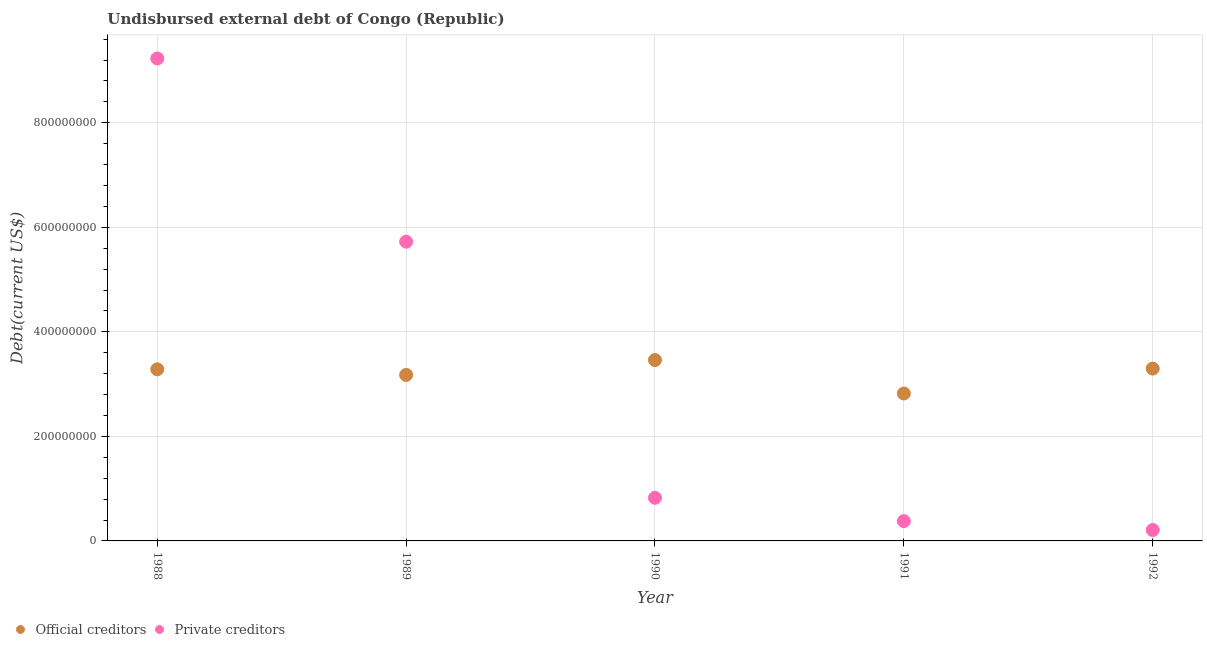What is the undisbursed external debt of official creditors in 1992?
Give a very brief answer. 3.30e+08. Across all years, what is the maximum undisbursed external debt of official creditors?
Give a very brief answer. 3.46e+08. Across all years, what is the minimum undisbursed external debt of private creditors?
Make the answer very short. 2.08e+07. What is the total undisbursed external debt of private creditors in the graph?
Offer a very short reply. 1.64e+09. What is the difference between the undisbursed external debt of private creditors in 1991 and that in 1992?
Your response must be concise. 1.71e+07. What is the difference between the undisbursed external debt of private creditors in 1992 and the undisbursed external debt of official creditors in 1991?
Your answer should be compact. -2.61e+08. What is the average undisbursed external debt of private creditors per year?
Offer a terse response. 3.27e+08. In the year 1988, what is the difference between the undisbursed external debt of official creditors and undisbursed external debt of private creditors?
Offer a very short reply. -5.95e+08. What is the ratio of the undisbursed external debt of official creditors in 1989 to that in 1991?
Your response must be concise. 1.13. Is the difference between the undisbursed external debt of official creditors in 1988 and 1992 greater than the difference between the undisbursed external debt of private creditors in 1988 and 1992?
Give a very brief answer. No. What is the difference between the highest and the second highest undisbursed external debt of official creditors?
Provide a succinct answer. 1.64e+07. What is the difference between the highest and the lowest undisbursed external debt of official creditors?
Your response must be concise. 6.40e+07. Is the sum of the undisbursed external debt of private creditors in 1988 and 1992 greater than the maximum undisbursed external debt of official creditors across all years?
Make the answer very short. Yes. Does the undisbursed external debt of private creditors monotonically increase over the years?
Provide a succinct answer. No. Is the undisbursed external debt of private creditors strictly greater than the undisbursed external debt of official creditors over the years?
Give a very brief answer. No. Is the undisbursed external debt of private creditors strictly less than the undisbursed external debt of official creditors over the years?
Ensure brevity in your answer.  No. How many dotlines are there?
Offer a very short reply. 2. What is the difference between two consecutive major ticks on the Y-axis?
Your answer should be compact. 2.00e+08. Are the values on the major ticks of Y-axis written in scientific E-notation?
Give a very brief answer. No. Does the graph contain grids?
Make the answer very short. Yes. How many legend labels are there?
Give a very brief answer. 2. What is the title of the graph?
Provide a short and direct response. Undisbursed external debt of Congo (Republic). Does "Nitrous oxide emissions" appear as one of the legend labels in the graph?
Offer a terse response. No. What is the label or title of the X-axis?
Offer a very short reply. Year. What is the label or title of the Y-axis?
Your response must be concise. Debt(current US$). What is the Debt(current US$) of Official creditors in 1988?
Offer a terse response. 3.28e+08. What is the Debt(current US$) of Private creditors in 1988?
Keep it short and to the point. 9.23e+08. What is the Debt(current US$) in Official creditors in 1989?
Provide a succinct answer. 3.18e+08. What is the Debt(current US$) in Private creditors in 1989?
Your response must be concise. 5.72e+08. What is the Debt(current US$) in Official creditors in 1990?
Ensure brevity in your answer.  3.46e+08. What is the Debt(current US$) in Private creditors in 1990?
Give a very brief answer. 8.25e+07. What is the Debt(current US$) of Official creditors in 1991?
Make the answer very short. 2.82e+08. What is the Debt(current US$) of Private creditors in 1991?
Make the answer very short. 3.79e+07. What is the Debt(current US$) of Official creditors in 1992?
Provide a short and direct response. 3.30e+08. What is the Debt(current US$) in Private creditors in 1992?
Ensure brevity in your answer.  2.08e+07. Across all years, what is the maximum Debt(current US$) in Official creditors?
Your answer should be very brief. 3.46e+08. Across all years, what is the maximum Debt(current US$) of Private creditors?
Your response must be concise. 9.23e+08. Across all years, what is the minimum Debt(current US$) of Official creditors?
Keep it short and to the point. 2.82e+08. Across all years, what is the minimum Debt(current US$) in Private creditors?
Provide a short and direct response. 2.08e+07. What is the total Debt(current US$) in Official creditors in the graph?
Your answer should be very brief. 1.60e+09. What is the total Debt(current US$) of Private creditors in the graph?
Make the answer very short. 1.64e+09. What is the difference between the Debt(current US$) in Official creditors in 1988 and that in 1989?
Keep it short and to the point. 1.07e+07. What is the difference between the Debt(current US$) in Private creditors in 1988 and that in 1989?
Offer a very short reply. 3.51e+08. What is the difference between the Debt(current US$) in Official creditors in 1988 and that in 1990?
Make the answer very short. -1.78e+07. What is the difference between the Debt(current US$) in Private creditors in 1988 and that in 1990?
Keep it short and to the point. 8.41e+08. What is the difference between the Debt(current US$) of Official creditors in 1988 and that in 1991?
Keep it short and to the point. 4.62e+07. What is the difference between the Debt(current US$) in Private creditors in 1988 and that in 1991?
Your answer should be compact. 8.85e+08. What is the difference between the Debt(current US$) of Official creditors in 1988 and that in 1992?
Your response must be concise. -1.40e+06. What is the difference between the Debt(current US$) in Private creditors in 1988 and that in 1992?
Offer a very short reply. 9.02e+08. What is the difference between the Debt(current US$) of Official creditors in 1989 and that in 1990?
Ensure brevity in your answer.  -2.85e+07. What is the difference between the Debt(current US$) in Private creditors in 1989 and that in 1990?
Your answer should be very brief. 4.90e+08. What is the difference between the Debt(current US$) of Official creditors in 1989 and that in 1991?
Your answer should be very brief. 3.55e+07. What is the difference between the Debt(current US$) of Private creditors in 1989 and that in 1991?
Your answer should be compact. 5.35e+08. What is the difference between the Debt(current US$) in Official creditors in 1989 and that in 1992?
Offer a terse response. -1.21e+07. What is the difference between the Debt(current US$) in Private creditors in 1989 and that in 1992?
Make the answer very short. 5.52e+08. What is the difference between the Debt(current US$) of Official creditors in 1990 and that in 1991?
Give a very brief answer. 6.40e+07. What is the difference between the Debt(current US$) of Private creditors in 1990 and that in 1991?
Offer a very short reply. 4.46e+07. What is the difference between the Debt(current US$) in Official creditors in 1990 and that in 1992?
Offer a very short reply. 1.64e+07. What is the difference between the Debt(current US$) in Private creditors in 1990 and that in 1992?
Offer a terse response. 6.17e+07. What is the difference between the Debt(current US$) in Official creditors in 1991 and that in 1992?
Give a very brief answer. -4.76e+07. What is the difference between the Debt(current US$) of Private creditors in 1991 and that in 1992?
Keep it short and to the point. 1.71e+07. What is the difference between the Debt(current US$) in Official creditors in 1988 and the Debt(current US$) in Private creditors in 1989?
Your answer should be compact. -2.44e+08. What is the difference between the Debt(current US$) in Official creditors in 1988 and the Debt(current US$) in Private creditors in 1990?
Give a very brief answer. 2.46e+08. What is the difference between the Debt(current US$) of Official creditors in 1988 and the Debt(current US$) of Private creditors in 1991?
Provide a short and direct response. 2.90e+08. What is the difference between the Debt(current US$) of Official creditors in 1988 and the Debt(current US$) of Private creditors in 1992?
Make the answer very short. 3.07e+08. What is the difference between the Debt(current US$) of Official creditors in 1989 and the Debt(current US$) of Private creditors in 1990?
Your answer should be very brief. 2.35e+08. What is the difference between the Debt(current US$) in Official creditors in 1989 and the Debt(current US$) in Private creditors in 1991?
Your answer should be very brief. 2.80e+08. What is the difference between the Debt(current US$) in Official creditors in 1989 and the Debt(current US$) in Private creditors in 1992?
Make the answer very short. 2.97e+08. What is the difference between the Debt(current US$) of Official creditors in 1990 and the Debt(current US$) of Private creditors in 1991?
Your response must be concise. 3.08e+08. What is the difference between the Debt(current US$) in Official creditors in 1990 and the Debt(current US$) in Private creditors in 1992?
Provide a short and direct response. 3.25e+08. What is the difference between the Debt(current US$) of Official creditors in 1991 and the Debt(current US$) of Private creditors in 1992?
Your answer should be very brief. 2.61e+08. What is the average Debt(current US$) in Official creditors per year?
Your response must be concise. 3.21e+08. What is the average Debt(current US$) in Private creditors per year?
Offer a terse response. 3.27e+08. In the year 1988, what is the difference between the Debt(current US$) of Official creditors and Debt(current US$) of Private creditors?
Provide a short and direct response. -5.95e+08. In the year 1989, what is the difference between the Debt(current US$) in Official creditors and Debt(current US$) in Private creditors?
Keep it short and to the point. -2.55e+08. In the year 1990, what is the difference between the Debt(current US$) in Official creditors and Debt(current US$) in Private creditors?
Provide a short and direct response. 2.64e+08. In the year 1991, what is the difference between the Debt(current US$) of Official creditors and Debt(current US$) of Private creditors?
Make the answer very short. 2.44e+08. In the year 1992, what is the difference between the Debt(current US$) of Official creditors and Debt(current US$) of Private creditors?
Offer a terse response. 3.09e+08. What is the ratio of the Debt(current US$) of Official creditors in 1988 to that in 1989?
Provide a short and direct response. 1.03. What is the ratio of the Debt(current US$) of Private creditors in 1988 to that in 1989?
Offer a very short reply. 1.61. What is the ratio of the Debt(current US$) of Official creditors in 1988 to that in 1990?
Ensure brevity in your answer.  0.95. What is the ratio of the Debt(current US$) of Private creditors in 1988 to that in 1990?
Provide a succinct answer. 11.19. What is the ratio of the Debt(current US$) of Official creditors in 1988 to that in 1991?
Keep it short and to the point. 1.16. What is the ratio of the Debt(current US$) in Private creditors in 1988 to that in 1991?
Your answer should be very brief. 24.35. What is the ratio of the Debt(current US$) of Official creditors in 1988 to that in 1992?
Your response must be concise. 1. What is the ratio of the Debt(current US$) in Private creditors in 1988 to that in 1992?
Provide a short and direct response. 44.28. What is the ratio of the Debt(current US$) of Official creditors in 1989 to that in 1990?
Your answer should be compact. 0.92. What is the ratio of the Debt(current US$) of Private creditors in 1989 to that in 1990?
Your answer should be compact. 6.94. What is the ratio of the Debt(current US$) in Official creditors in 1989 to that in 1991?
Ensure brevity in your answer.  1.13. What is the ratio of the Debt(current US$) of Private creditors in 1989 to that in 1991?
Provide a short and direct response. 15.1. What is the ratio of the Debt(current US$) in Official creditors in 1989 to that in 1992?
Provide a short and direct response. 0.96. What is the ratio of the Debt(current US$) of Private creditors in 1989 to that in 1992?
Your answer should be compact. 27.46. What is the ratio of the Debt(current US$) of Official creditors in 1990 to that in 1991?
Provide a short and direct response. 1.23. What is the ratio of the Debt(current US$) in Private creditors in 1990 to that in 1991?
Give a very brief answer. 2.18. What is the ratio of the Debt(current US$) in Official creditors in 1990 to that in 1992?
Your answer should be very brief. 1.05. What is the ratio of the Debt(current US$) in Private creditors in 1990 to that in 1992?
Provide a succinct answer. 3.96. What is the ratio of the Debt(current US$) of Official creditors in 1991 to that in 1992?
Your response must be concise. 0.86. What is the ratio of the Debt(current US$) of Private creditors in 1991 to that in 1992?
Make the answer very short. 1.82. What is the difference between the highest and the second highest Debt(current US$) of Official creditors?
Ensure brevity in your answer.  1.64e+07. What is the difference between the highest and the second highest Debt(current US$) of Private creditors?
Make the answer very short. 3.51e+08. What is the difference between the highest and the lowest Debt(current US$) in Official creditors?
Ensure brevity in your answer.  6.40e+07. What is the difference between the highest and the lowest Debt(current US$) in Private creditors?
Provide a succinct answer. 9.02e+08. 